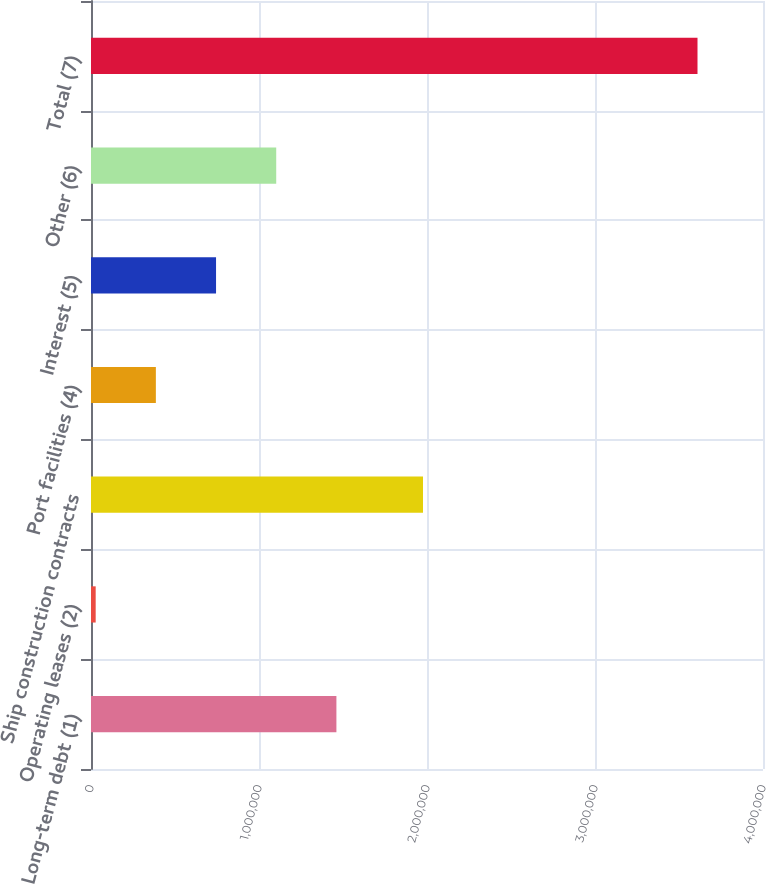Convert chart to OTSL. <chart><loc_0><loc_0><loc_500><loc_500><bar_chart><fcel>Long-term debt (1)<fcel>Operating leases (2)<fcel>Ship construction contracts<fcel>Port facilities (4)<fcel>Interest (5)<fcel>Other (6)<fcel>Total (7)<nl><fcel>1.46076e+06<fcel>27853<fcel>1.97622e+06<fcel>386080<fcel>744306<fcel>1.10253e+06<fcel>3.61012e+06<nl></chart> 